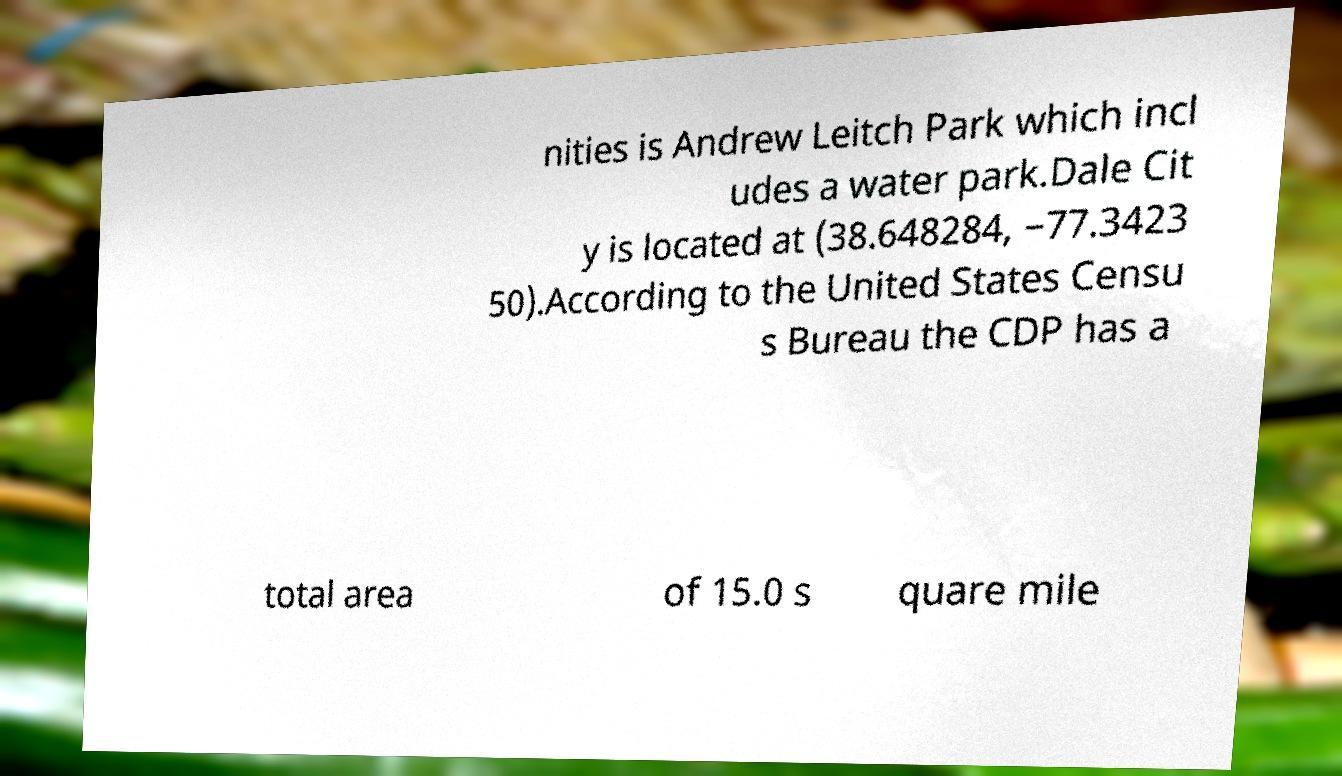Can you accurately transcribe the text from the provided image for me? nities is Andrew Leitch Park which incl udes a water park.Dale Cit y is located at (38.648284, −77.3423 50).According to the United States Censu s Bureau the CDP has a total area of 15.0 s quare mile 